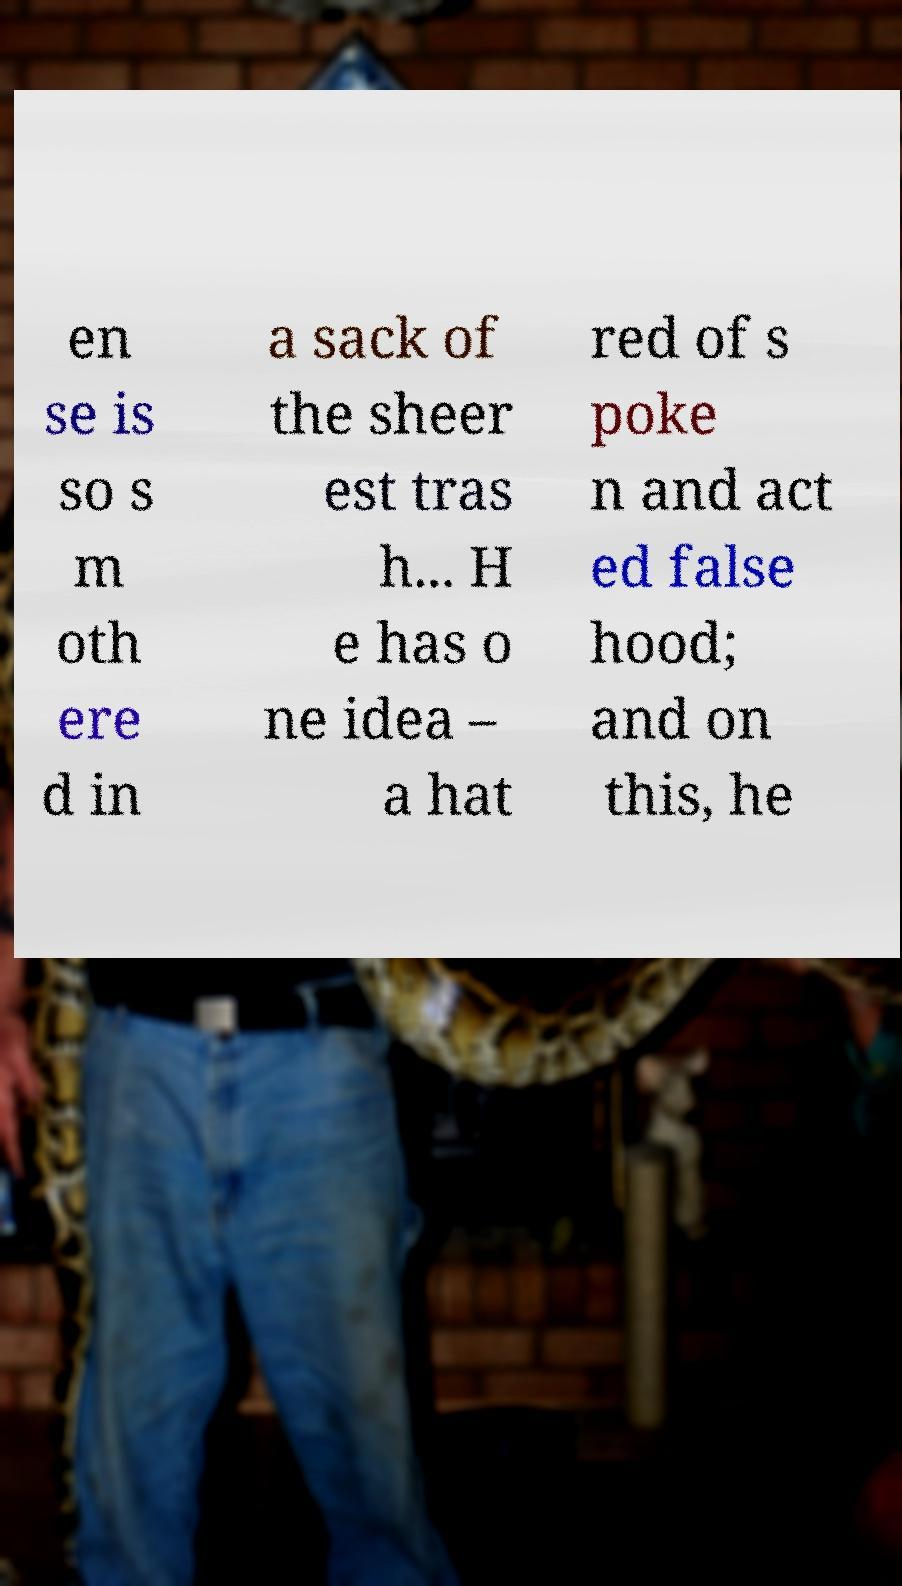Please identify and transcribe the text found in this image. en se is so s m oth ere d in a sack of the sheer est tras h... H e has o ne idea – a hat red of s poke n and act ed false hood; and on this, he 